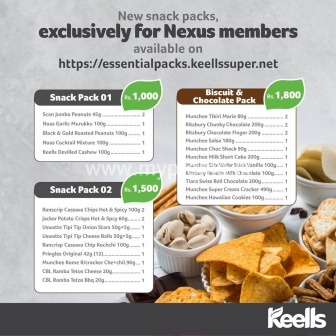How would you creatively use these snack packs as part of a gift? These snack packs would make an excellent centerpiece for a personalized gift basket. Imagine creating themed gift baskets for different occasions:

**For a birthday celebration:** Wrap the snacks in vibrant, colorful paper and add a festive ribbon. Include a handwritten birthday card and perhaps some party favors like hats and blowers to complement the cheerful array of snacks.

**For a thank you gift:** Arrange the snacks in a sleek, elegant basket, perhaps adding a bottle of wine or a selection of fine teas to accompany the Biscuit & Chocolate Pack. A heartfelt thank you note would be the perfect finishing touch.

**For a cozy winter surprise:** Line a wicker basket with a soft, cozy blanket, and nestle the snacks inside. Add in a few wintertime treats like hot cocoa mix, marshmallows, and perhaps a pair of warm socks. This basket would be perfect for a cozy night in front of the fire.

By thoughtfully arranging these snack packs and adding personal touches, you can create a gift that’s not only delicious but also shows a lot of care and effort. 